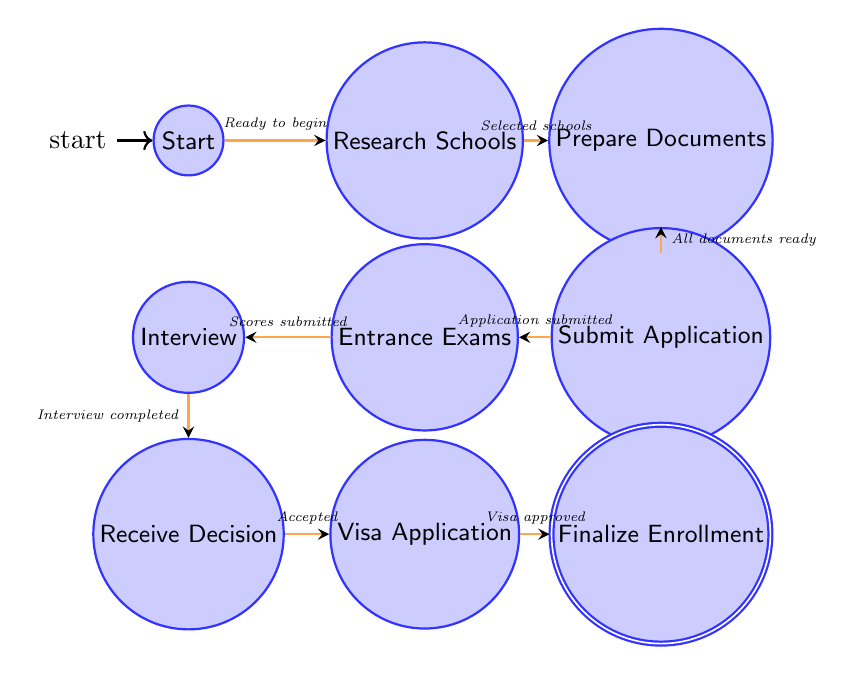What is the first state in the admissions process? The first state in the admissions process is indicated as the starting point of the diagram, which is labeled as "Start."
Answer: Start How many states are in the diagram? By counting the states represented in the diagram, including Start and Finalize Enrollment, there are a total of nine states.
Answer: Nine What is the condition required to move from "Prepare Documents" to "Submit Application"? The transition from "Prepare Documents" to "Submit Application" requires that all necessary documents are ready, as indicated by the condition labeled "All documents prepared."
Answer: All documents prepared Which state comes after "Entrance Exams"? According to the transitions defined in the diagram, the state that follows "Entrance Exams" is "Interview."
Answer: Interview What is the final state of the admissions process? The final state in the admissions process, as shown in the diagram, is labeled "Finalize Enrollment."
Answer: Finalize Enrollment What condition leads to moving from "Receive Decision" to "Visa Application"? The transition from "Receive Decision" to "Visa Application" occurs when the student has received an acceptance letter, as shown in the diagram with the condition labeled "Received acceptance letter."
Answer: Received acceptance letter Which two states are directly connected without any other state in between? The states "Interview" and "Receive Decision" are directly connected without any intervening states, as indicated by a direct transition in the diagram.
Answer: Interview and Receive Decision What must happen before an interview can be conducted according to the diagram? Before an interview can be conducted, the entrance exam scores must be submitted and an interview must be requested, as stated in the transition condition labeled "Scores submitted and interview requested."
Answer: Scores submitted and interview requested 